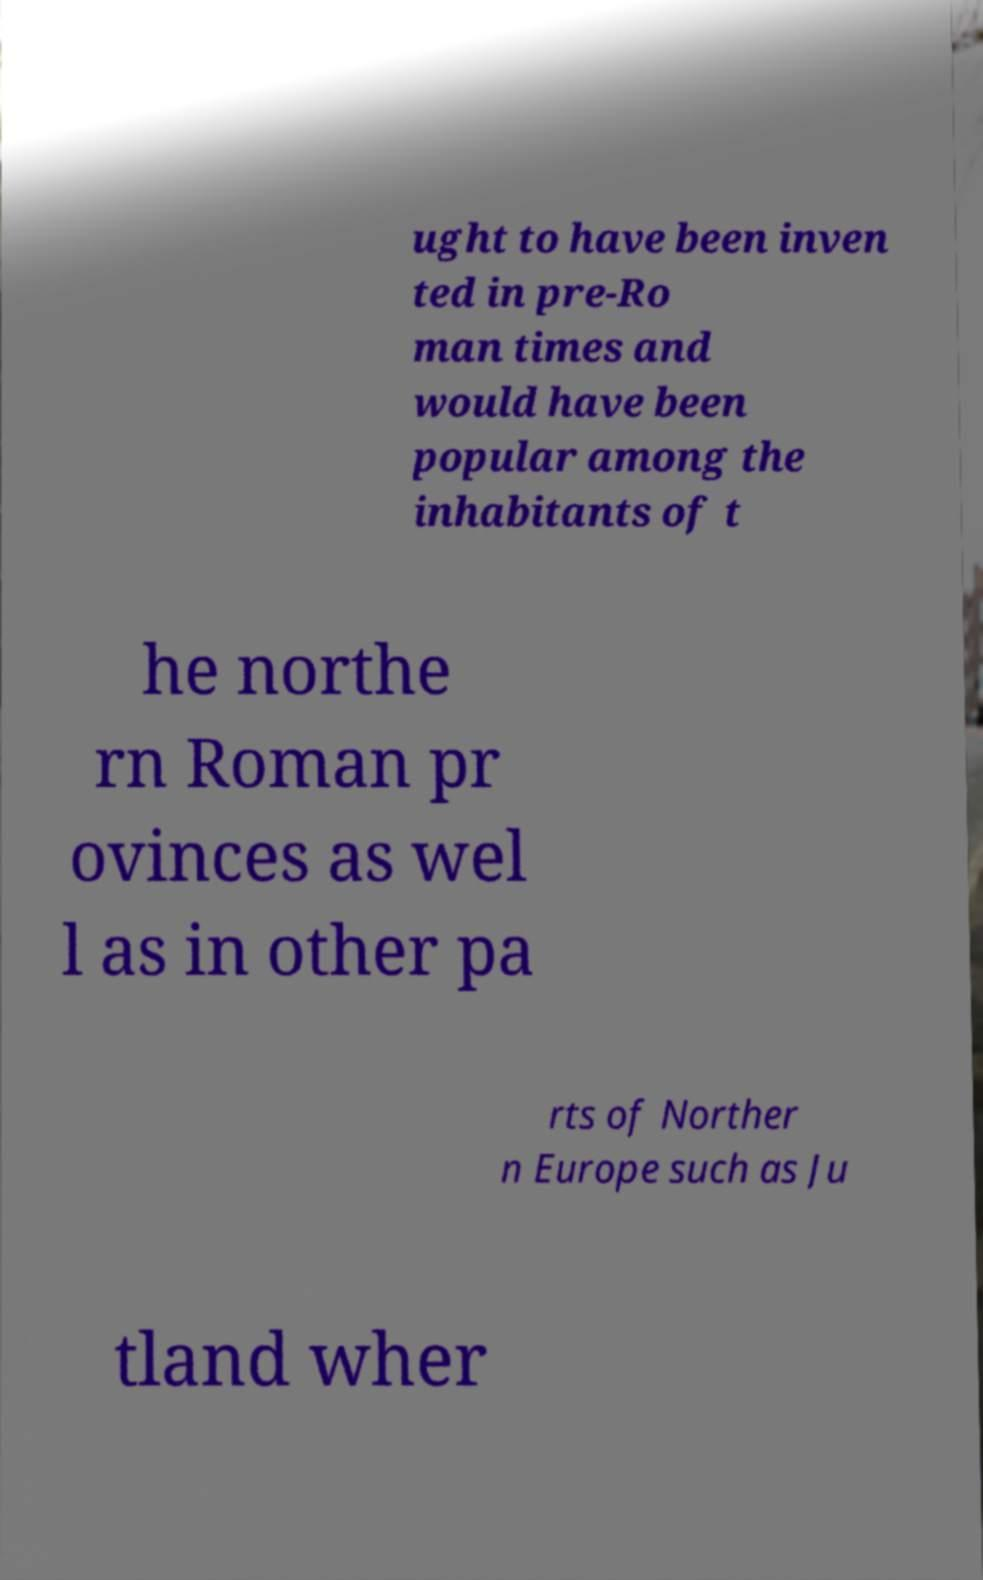Can you read and provide the text displayed in the image?This photo seems to have some interesting text. Can you extract and type it out for me? ught to have been inven ted in pre-Ro man times and would have been popular among the inhabitants of t he northe rn Roman pr ovinces as wel l as in other pa rts of Norther n Europe such as Ju tland wher 